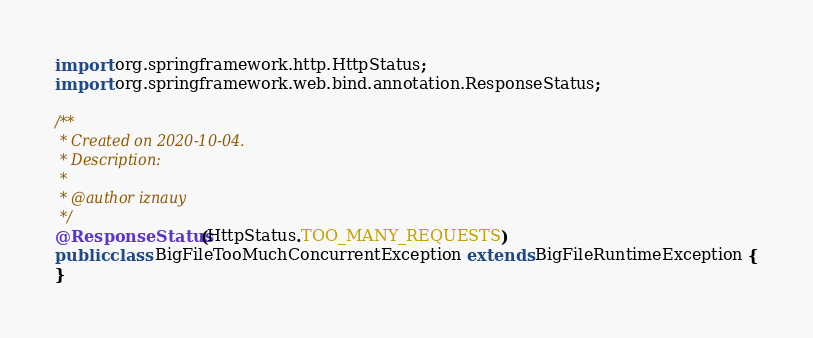<code> <loc_0><loc_0><loc_500><loc_500><_Java_>
import org.springframework.http.HttpStatus;
import org.springframework.web.bind.annotation.ResponseStatus;

/**
 * Created on 2020-10-04.
 * Description:
 *
 * @author iznauy
 */
@ResponseStatus(HttpStatus.TOO_MANY_REQUESTS)
public class BigFileTooMuchConcurrentException extends BigFileRuntimeException {
}
</code> 